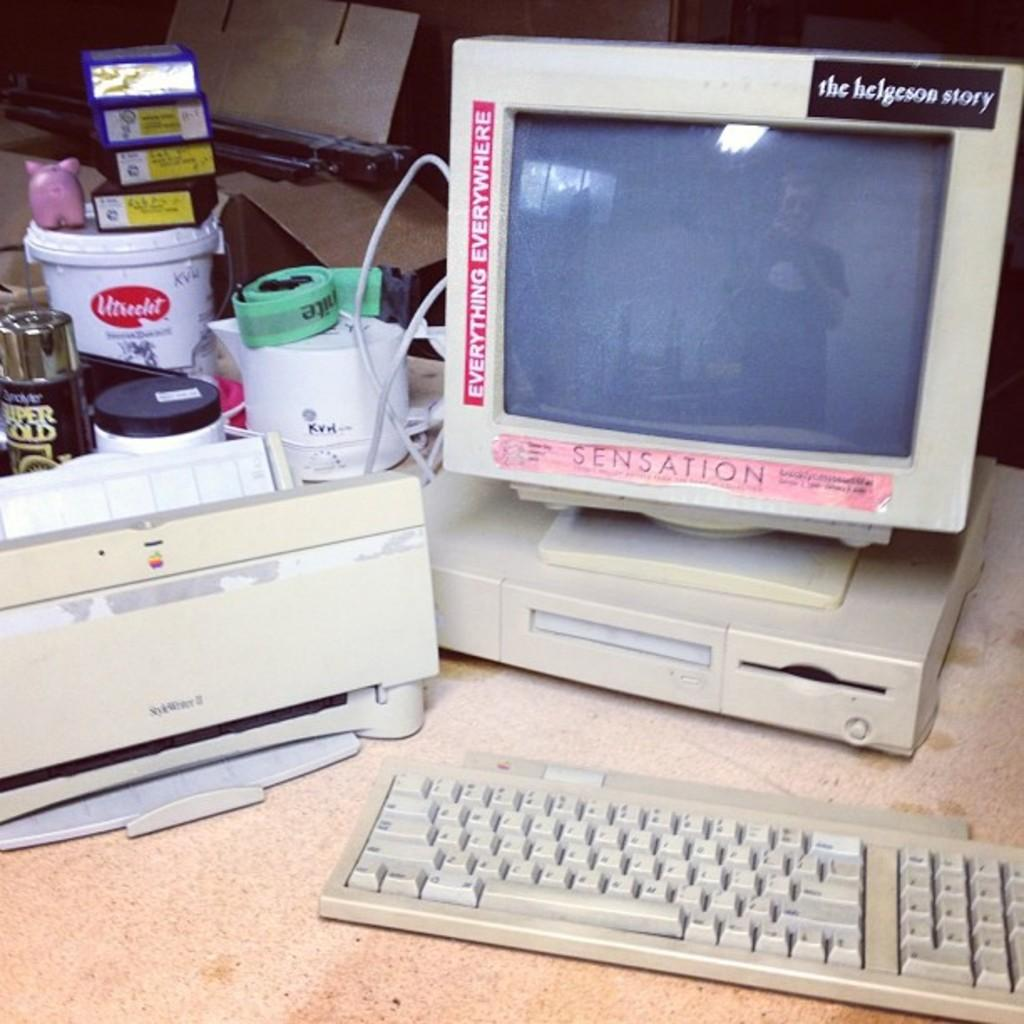<image>
Provide a brief description of the given image. An older Apple computer and printer, with stickers on the monitor frame reading SENSATION, EVERYTHING EVERYWHERE, and the helgeson story. 